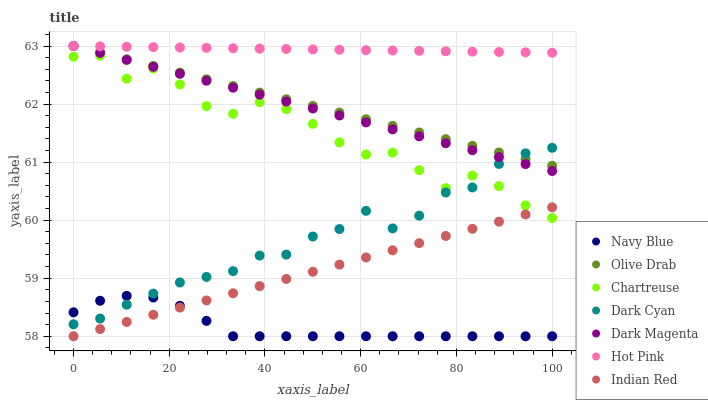Does Navy Blue have the minimum area under the curve?
Answer yes or no. Yes. Does Hot Pink have the maximum area under the curve?
Answer yes or no. Yes. Does Hot Pink have the minimum area under the curve?
Answer yes or no. No. Does Navy Blue have the maximum area under the curve?
Answer yes or no. No. Is Indian Red the smoothest?
Answer yes or no. Yes. Is Chartreuse the roughest?
Answer yes or no. Yes. Is Navy Blue the smoothest?
Answer yes or no. No. Is Navy Blue the roughest?
Answer yes or no. No. Does Navy Blue have the lowest value?
Answer yes or no. Yes. Does Hot Pink have the lowest value?
Answer yes or no. No. Does Olive Drab have the highest value?
Answer yes or no. Yes. Does Navy Blue have the highest value?
Answer yes or no. No. Is Indian Red less than Dark Magenta?
Answer yes or no. Yes. Is Hot Pink greater than Indian Red?
Answer yes or no. Yes. Does Olive Drab intersect Hot Pink?
Answer yes or no. Yes. Is Olive Drab less than Hot Pink?
Answer yes or no. No. Is Olive Drab greater than Hot Pink?
Answer yes or no. No. Does Indian Red intersect Dark Magenta?
Answer yes or no. No. 